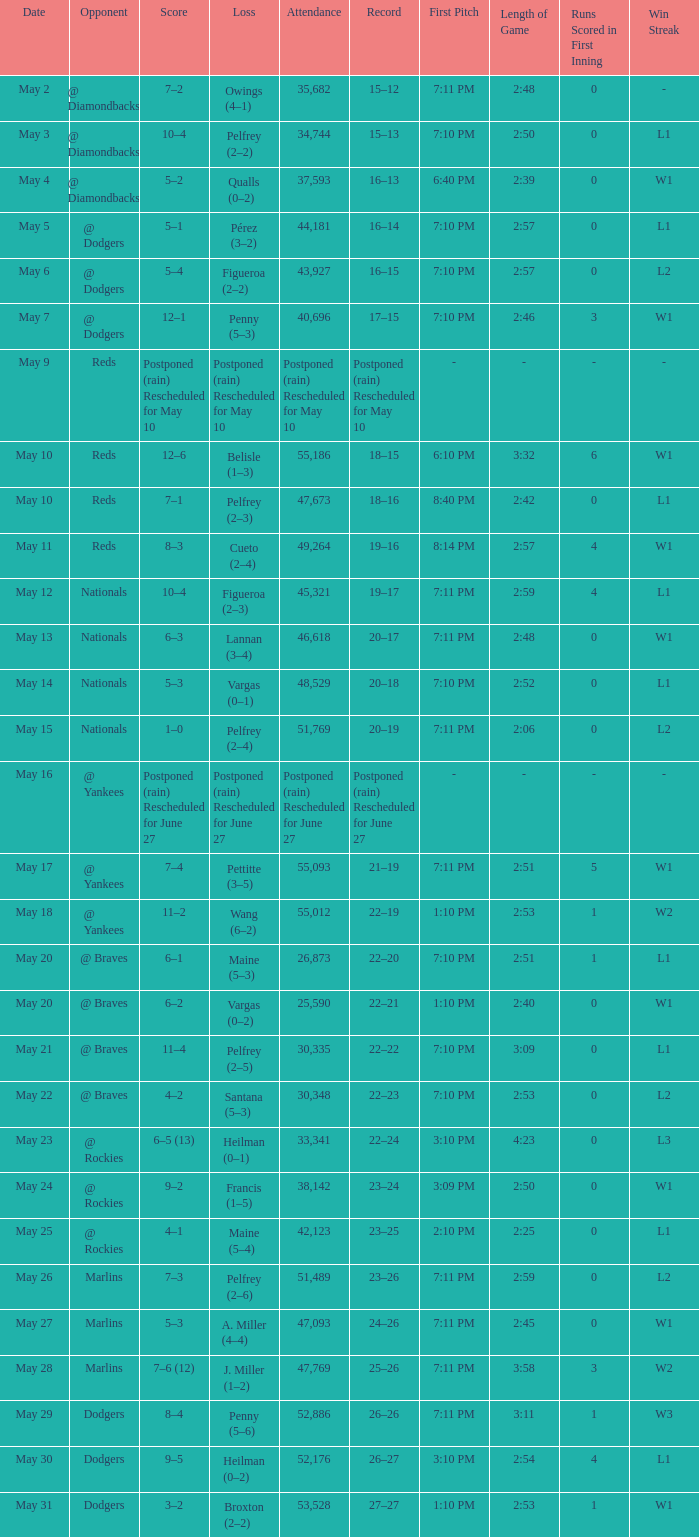Attendance of 30,335 had what record? 22–22. 